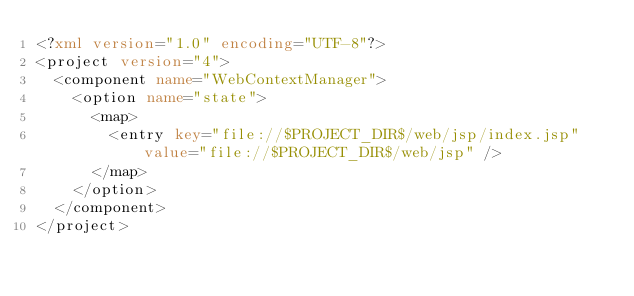Convert code to text. <code><loc_0><loc_0><loc_500><loc_500><_XML_><?xml version="1.0" encoding="UTF-8"?>
<project version="4">
  <component name="WebContextManager">
    <option name="state">
      <map>
        <entry key="file://$PROJECT_DIR$/web/jsp/index.jsp" value="file://$PROJECT_DIR$/web/jsp" />
      </map>
    </option>
  </component>
</project></code> 